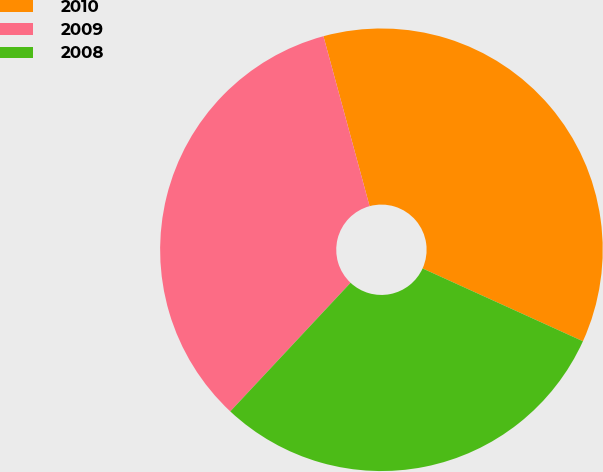<chart> <loc_0><loc_0><loc_500><loc_500><pie_chart><fcel>2010<fcel>2009<fcel>2008<nl><fcel>36.0%<fcel>33.81%<fcel>30.18%<nl></chart> 